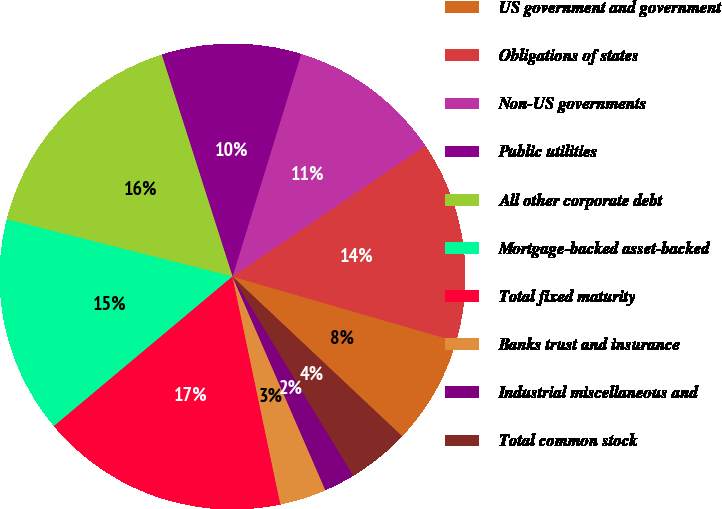Convert chart to OTSL. <chart><loc_0><loc_0><loc_500><loc_500><pie_chart><fcel>US government and government<fcel>Obligations of states<fcel>Non-US governments<fcel>Public utilities<fcel>All other corporate debt<fcel>Mortgage-backed asset-backed<fcel>Total fixed maturity<fcel>Banks trust and insurance<fcel>Industrial miscellaneous and<fcel>Total common stock<nl><fcel>7.53%<fcel>13.98%<fcel>10.75%<fcel>9.68%<fcel>16.13%<fcel>15.05%<fcel>17.2%<fcel>3.23%<fcel>2.15%<fcel>4.3%<nl></chart> 